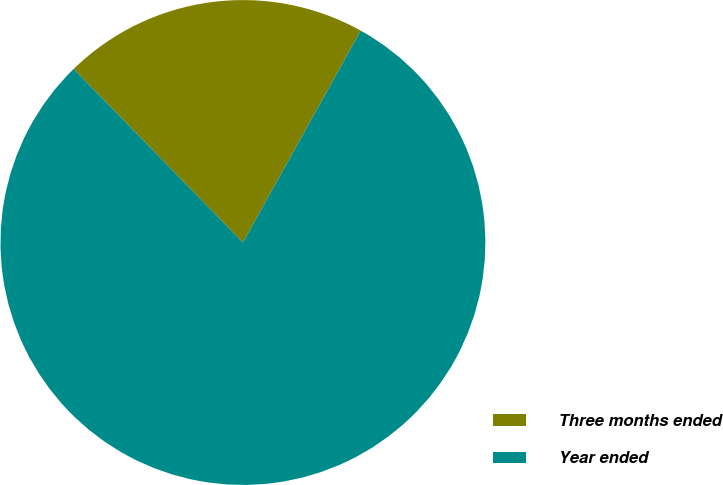Convert chart. <chart><loc_0><loc_0><loc_500><loc_500><pie_chart><fcel>Three months ended<fcel>Year ended<nl><fcel>20.38%<fcel>79.62%<nl></chart> 